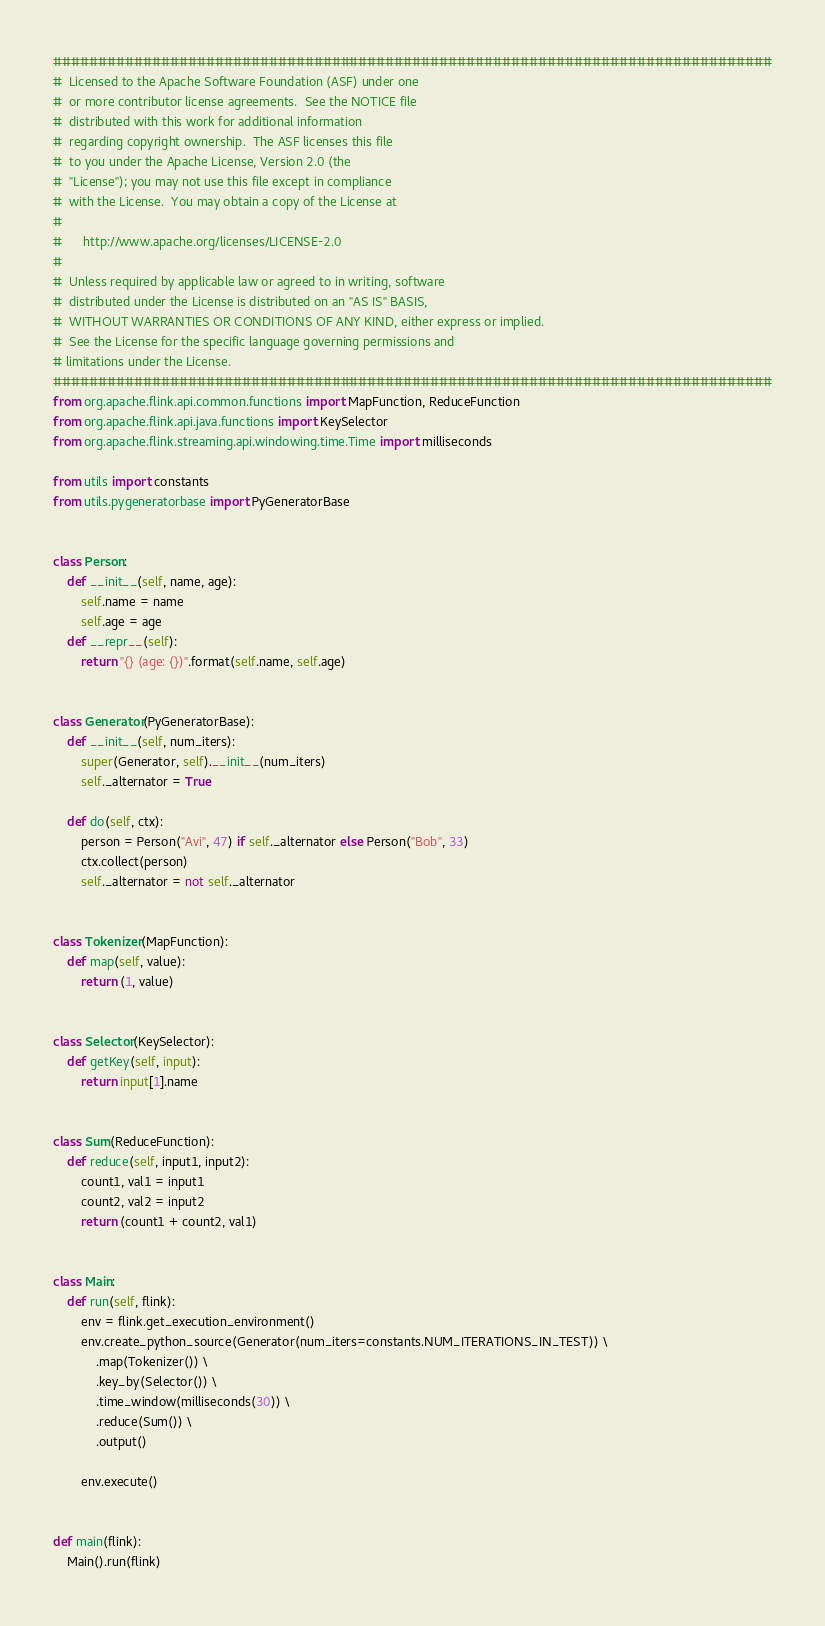Convert code to text. <code><loc_0><loc_0><loc_500><loc_500><_Python_>################################################################################
#  Licensed to the Apache Software Foundation (ASF) under one
#  or more contributor license agreements.  See the NOTICE file
#  distributed with this work for additional information
#  regarding copyright ownership.  The ASF licenses this file
#  to you under the Apache License, Version 2.0 (the
#  "License"); you may not use this file except in compliance
#  with the License.  You may obtain a copy of the License at
#
#      http://www.apache.org/licenses/LICENSE-2.0
#
#  Unless required by applicable law or agreed to in writing, software
#  distributed under the License is distributed on an "AS IS" BASIS,
#  WITHOUT WARRANTIES OR CONDITIONS OF ANY KIND, either express or implied.
#  See the License for the specific language governing permissions and
# limitations under the License.
################################################################################
from org.apache.flink.api.common.functions import MapFunction, ReduceFunction
from org.apache.flink.api.java.functions import KeySelector
from org.apache.flink.streaming.api.windowing.time.Time import milliseconds

from utils import constants
from utils.pygeneratorbase import PyGeneratorBase


class Person:
    def __init__(self, name, age):
        self.name = name
        self.age = age
    def __repr__(self):
        return "{} (age: {})".format(self.name, self.age)


class Generator(PyGeneratorBase):
    def __init__(self, num_iters):
        super(Generator, self).__init__(num_iters)
        self._alternator = True

    def do(self, ctx):
        person = Person("Avi", 47) if self._alternator else Person("Bob", 33)
        ctx.collect(person)
        self._alternator = not self._alternator


class Tokenizer(MapFunction):
    def map(self, value):
        return (1, value)


class Selector(KeySelector):
    def getKey(self, input):
        return input[1].name


class Sum(ReduceFunction):
    def reduce(self, input1, input2):
        count1, val1 = input1
        count2, val2 = input2
        return (count1 + count2, val1)


class Main:
    def run(self, flink):
        env = flink.get_execution_environment()
        env.create_python_source(Generator(num_iters=constants.NUM_ITERATIONS_IN_TEST)) \
            .map(Tokenizer()) \
            .key_by(Selector()) \
            .time_window(milliseconds(30)) \
            .reduce(Sum()) \
            .output()

        env.execute()


def main(flink):
    Main().run(flink)
</code> 